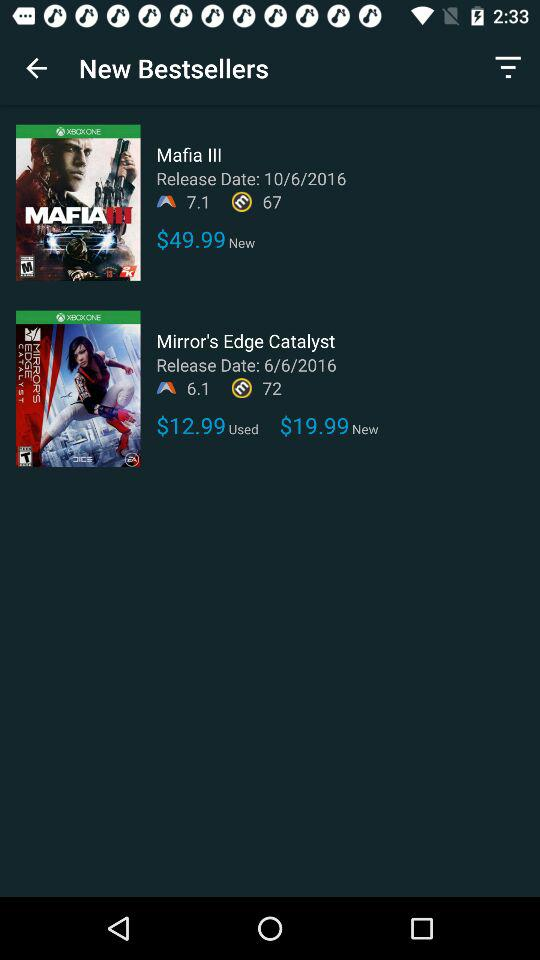Is "Mafia III" available on PlayStation?
When the provided information is insufficient, respond with <no answer>. <no answer> 